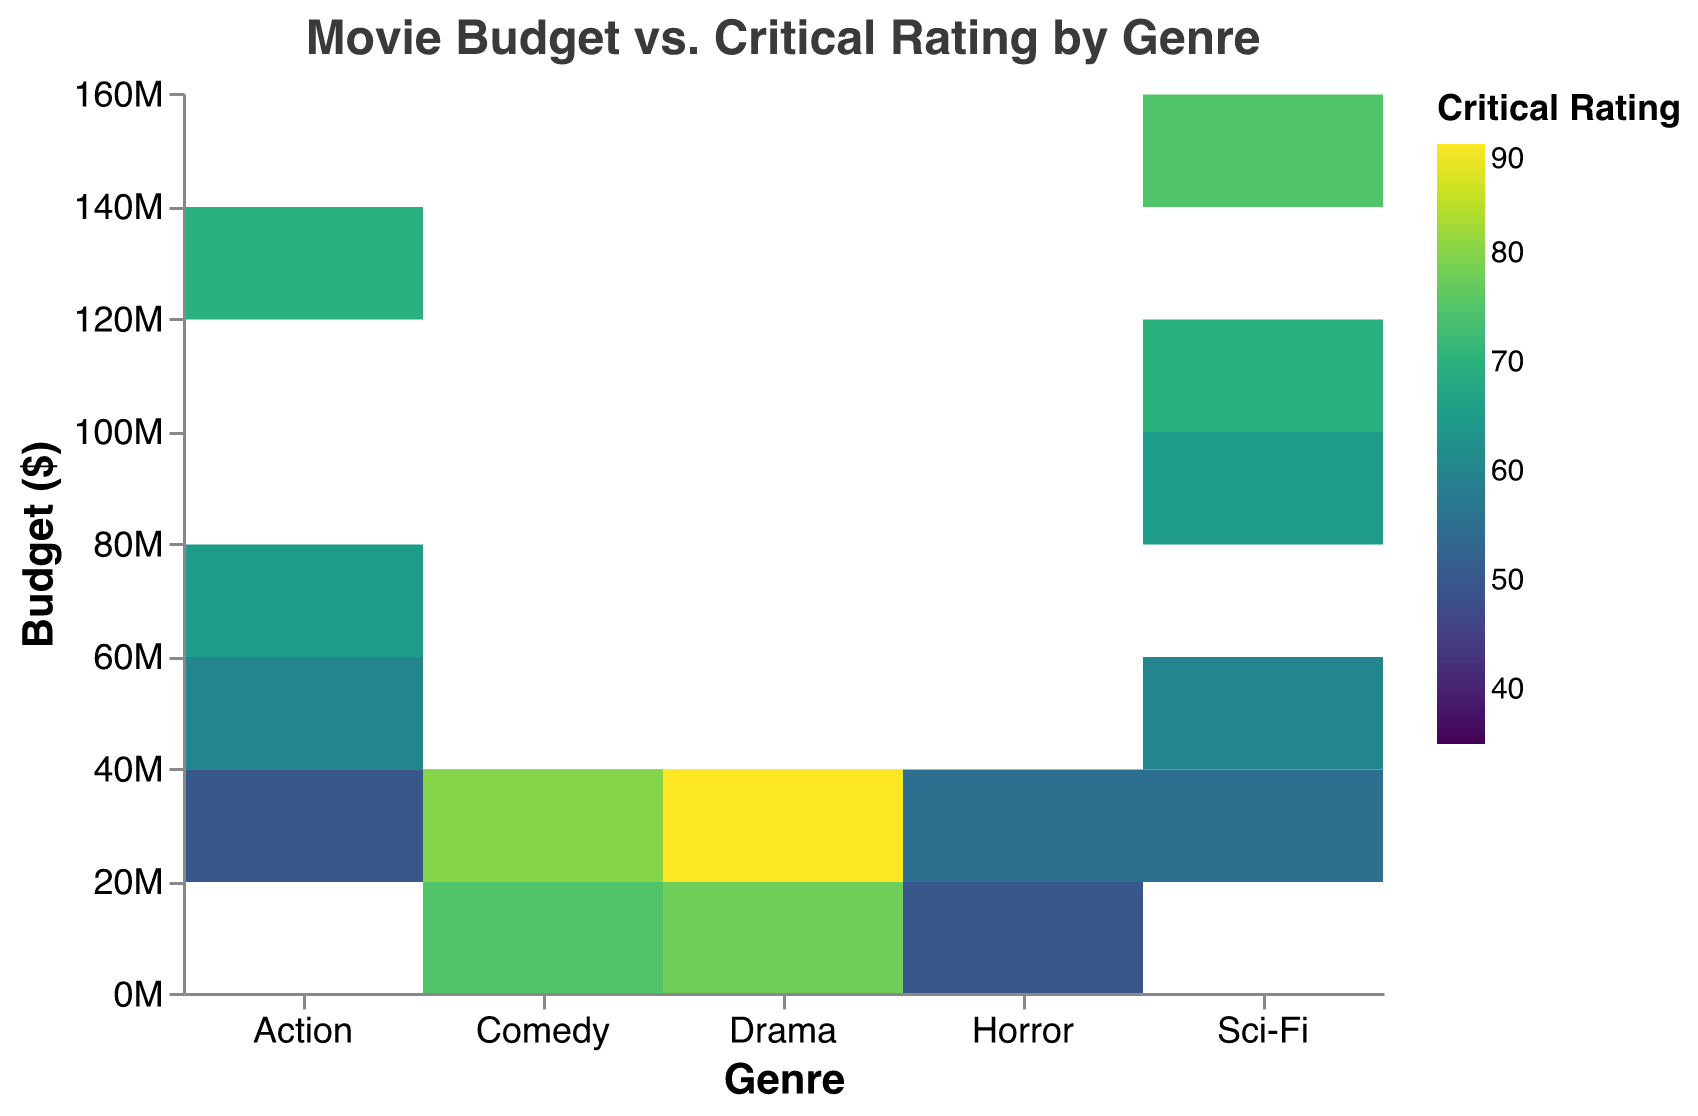What is the title of the heatmap? The title of the heatmap is often displayed prominently at the top of the figure. It summarizes the content and scope of the visualization. In this case, the title is "Movie Budget vs. Critical Rating by Genre."
Answer: Movie Budget vs. Critical Rating by Genre Which genre has the highest-rated movie, and what is the budget for that movie? To find the highest-rated movie, look for the darkest or highest color intensity on the "Rating" scale. In the heatmap, Drama has the highest rating with a budget of $30 million.
Answer: Drama, $30 million What is the relationship between budget and critical rating for horror movies? To understand this, observe the color pattern within the "Horror" genre column. You can see that higher budgets come with somewhat better ratings, but there is not a strict linear relationship as some low-budget horror films also have relatively high ratings.
Answer: Higher budgets generally get better ratings, but not consistently Which genre has the most movies with budgets between $10 million and $20 million? To answer this, observe the y-axis for the budget range of $10 million to $20 million, and check which genre column has the most individual color blocks (data points). Comedy and Drama both have movies in this budget range.
Answer: Comedy and Drama Compare the average ratings of movies with budgets below $10 million across all genres. Which genre has the highest average rating? For this, first identify all movies with budgets below $10 million. Then, calculate the average ratings across different genres for these movies:
- Horror: (35, 40, 50) => (35+40+50)/3 = 41.67
- Comedy: (60) => 60
- Drama: (75, 80) => (75+80)/2 = 77.5
- Action: (50) => 50
Drama has the highest average rating for movies with budgets below $10 million.
Answer: Drama Is there a particular genre that shows a wide range of ratings regardless of budget? Observe the color spread (ratings) within each genre's column. Horror shows a wider range of ratings from 35 to 55 across different budgets, indicating diverse critical receptions.
Answer: Horror How do the critical ratings for Sci-Fi movies compare between higher and lower budgets? Observe the Sci-Fi genre's column. Higher-budget Sci-Fi movies (e.g., $100 million and $150 million) tend to have higher ratings (70 and 75, respectively) compared to lower-budget ones (e.g., $30 million and $50 million) with ratings of 55 and 60.
Answer: Higher-budget Sci-Fi movies generally have better ratings What budget range in Action movies has the highest proportion of better ratings (above 60)? Identify the budget ranges in the Action genre column and note the proportions of ratings above 60. Action movies with budgets between $50 million and $120 million are mostly rated above 60.
Answer: $50 million to $120 million What is the average rating for Drama movies? Sum the ratings for Drama movies and divide by the number of movies: (85, 75, 80, 90, 78). Total is 408. There are 5 Drama movies. So, 408/5 = 81.6.
Answer: 81.6 